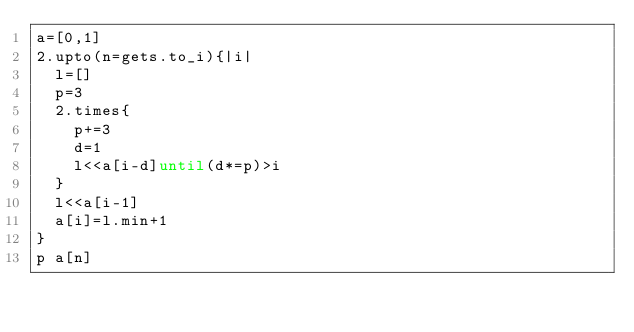Convert code to text. <code><loc_0><loc_0><loc_500><loc_500><_Ruby_>a=[0,1]
2.upto(n=gets.to_i){|i|
  l=[]
  p=3
  2.times{
    p+=3
    d=1
    l<<a[i-d]until(d*=p)>i
  }
  l<<a[i-1]
  a[i]=l.min+1
}
p a[n]</code> 